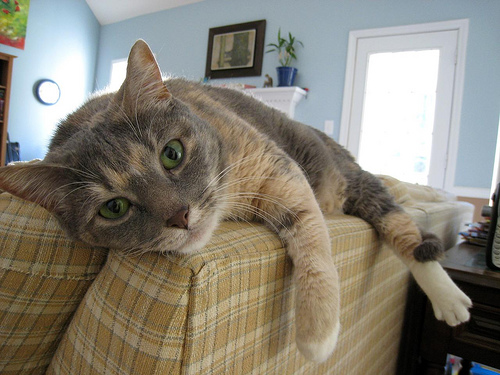If this cat could talk, what might it say about its current situation? If this cat could speak, it might say something along the lines of, 'I've found the perfect spot for my afternoon nap, and I'm just enjoying the warmth of the sunlight and the tranquility of my home.' 